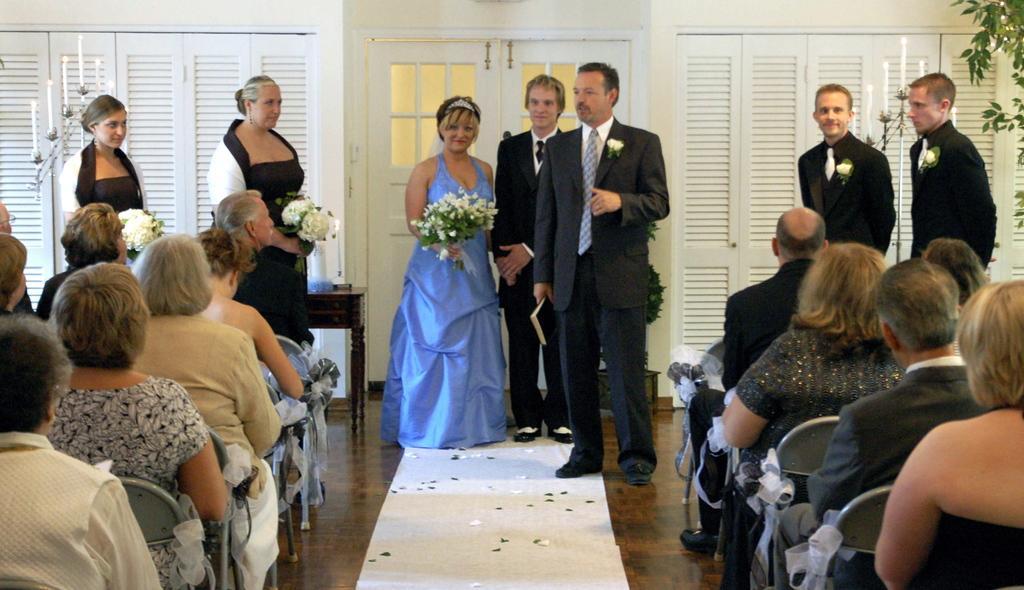Could you give a brief overview of what you see in this image? In this picture we can see a group of people were some are sitting on chairs and some are standing on the floor and holding flower bouquets with their hands, white carpet, leaves and in the background we can see cupboards and doors. 